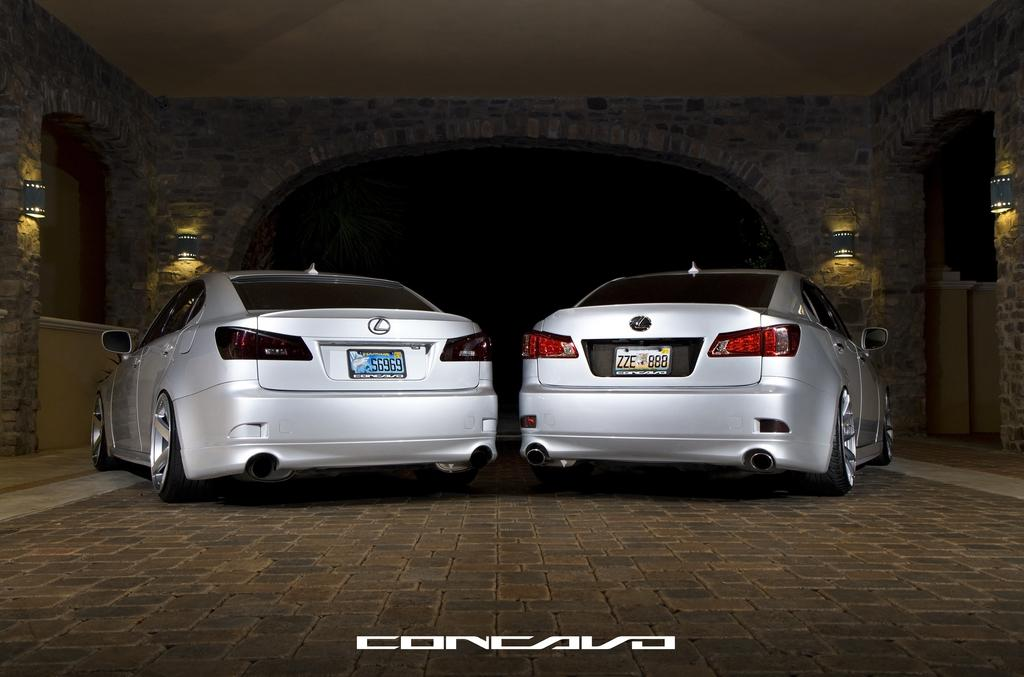What is the main subject in the center of the image? There are cars in the center of the image. What can be seen in the background of the image? There is an arch in the background of the image, and lights are placed on the wall. What type of meat is hanging from the arch in the image? There is no meat present in the image; the arch is a separate architectural feature in the background. 